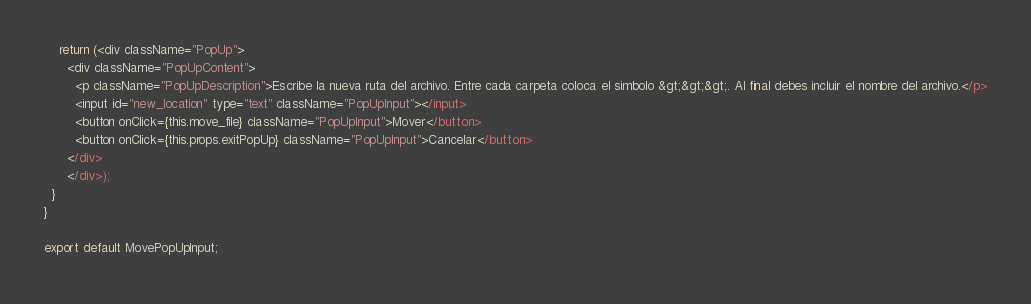<code> <loc_0><loc_0><loc_500><loc_500><_JavaScript_>    return (<div className="PopUp">
      <div className="PopUpContent">
        <p className="PopUpDescription">Escribe la nueva ruta del archivo. Entre cada carpeta coloca el simbolo &gt;&gt;&gt;. Al final debes incluir el nombre del archivo.</p>
        <input id="new_location" type="text" className="PopUpInput"></input>
        <button onClick={this.move_file} className="PopUpInput">Mover</button>
        <button onClick={this.props.exitPopUp} className="PopUpInput">Cancelar</button>
      </div>
      </div>);
  }
}

export default MovePopUpInput;
</code> 